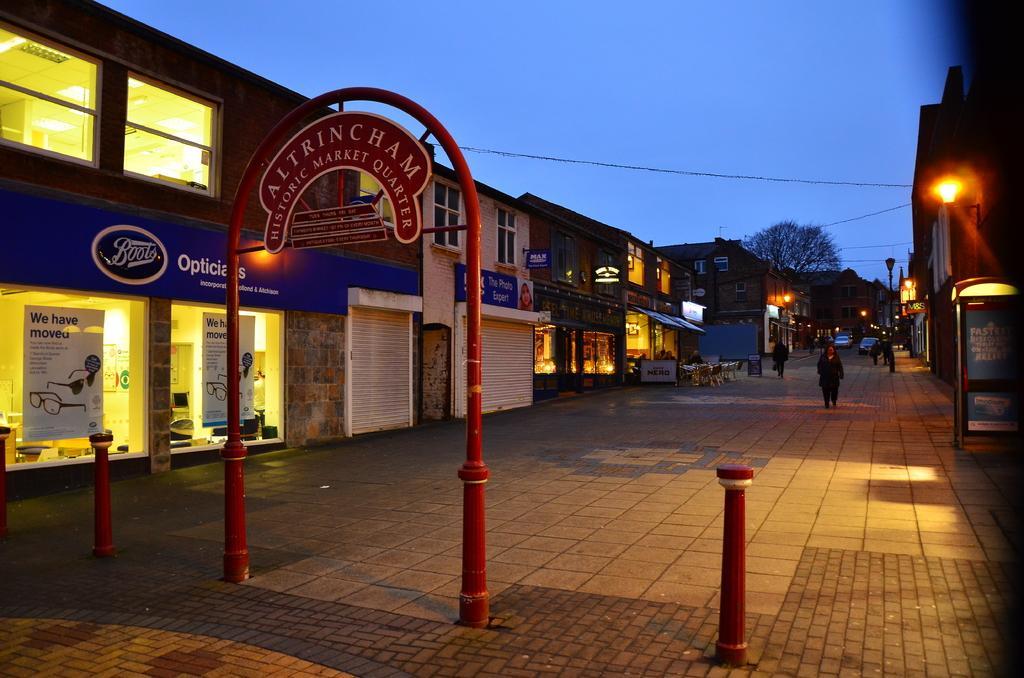Could you give a brief overview of what you see in this image? In this image there is a floor in the bottom of this image, and there are some buildings as we can see in middle of this image. There are some persons standing on the right side of this image and there is one tree on the top side to these persons, and there is a blue sky on the top of this image. There is a red color object placed on the bottom of this image. 